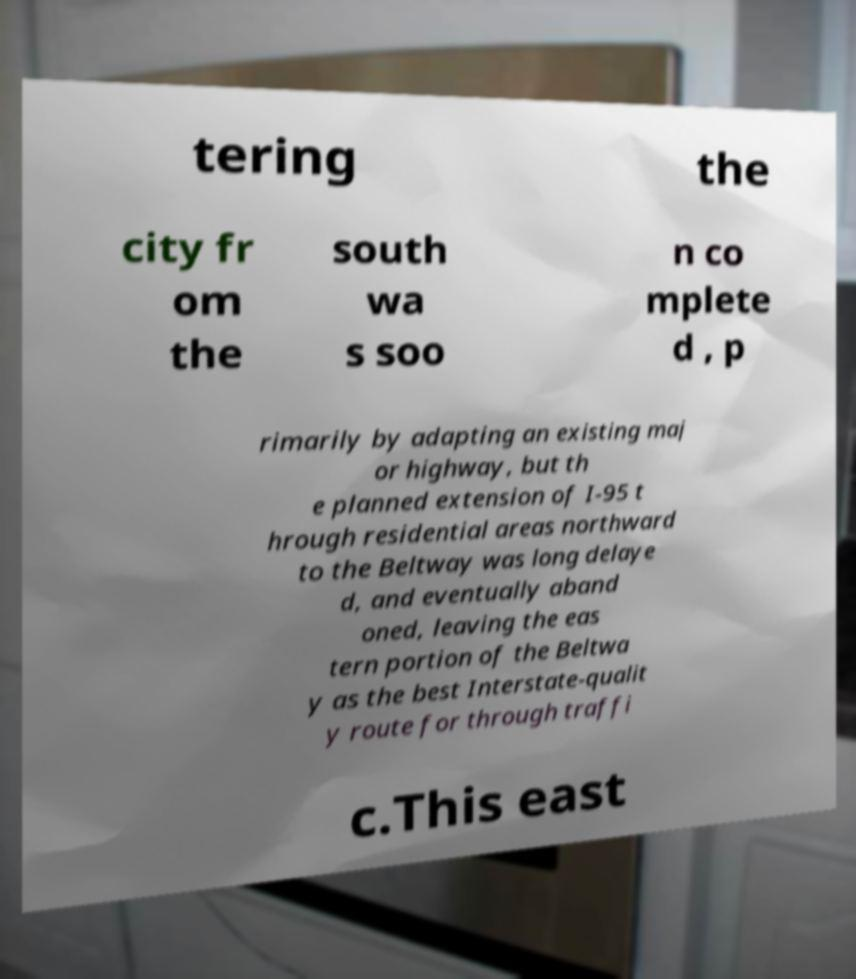Can you read and provide the text displayed in the image?This photo seems to have some interesting text. Can you extract and type it out for me? tering the city fr om the south wa s soo n co mplete d , p rimarily by adapting an existing maj or highway, but th e planned extension of I-95 t hrough residential areas northward to the Beltway was long delaye d, and eventually aband oned, leaving the eas tern portion of the Beltwa y as the best Interstate-qualit y route for through traffi c.This east 